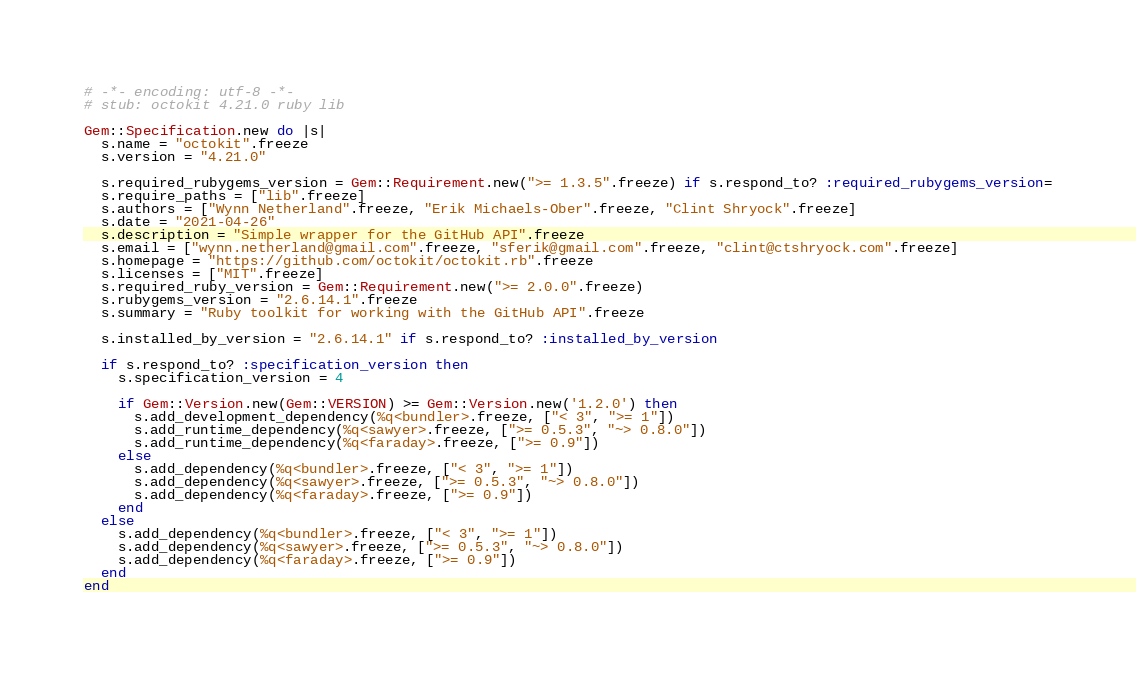Convert code to text. <code><loc_0><loc_0><loc_500><loc_500><_Ruby_># -*- encoding: utf-8 -*-
# stub: octokit 4.21.0 ruby lib

Gem::Specification.new do |s|
  s.name = "octokit".freeze
  s.version = "4.21.0"

  s.required_rubygems_version = Gem::Requirement.new(">= 1.3.5".freeze) if s.respond_to? :required_rubygems_version=
  s.require_paths = ["lib".freeze]
  s.authors = ["Wynn Netherland".freeze, "Erik Michaels-Ober".freeze, "Clint Shryock".freeze]
  s.date = "2021-04-26"
  s.description = "Simple wrapper for the GitHub API".freeze
  s.email = ["wynn.netherland@gmail.com".freeze, "sferik@gmail.com".freeze, "clint@ctshryock.com".freeze]
  s.homepage = "https://github.com/octokit/octokit.rb".freeze
  s.licenses = ["MIT".freeze]
  s.required_ruby_version = Gem::Requirement.new(">= 2.0.0".freeze)
  s.rubygems_version = "2.6.14.1".freeze
  s.summary = "Ruby toolkit for working with the GitHub API".freeze

  s.installed_by_version = "2.6.14.1" if s.respond_to? :installed_by_version

  if s.respond_to? :specification_version then
    s.specification_version = 4

    if Gem::Version.new(Gem::VERSION) >= Gem::Version.new('1.2.0') then
      s.add_development_dependency(%q<bundler>.freeze, ["< 3", ">= 1"])
      s.add_runtime_dependency(%q<sawyer>.freeze, [">= 0.5.3", "~> 0.8.0"])
      s.add_runtime_dependency(%q<faraday>.freeze, [">= 0.9"])
    else
      s.add_dependency(%q<bundler>.freeze, ["< 3", ">= 1"])
      s.add_dependency(%q<sawyer>.freeze, [">= 0.5.3", "~> 0.8.0"])
      s.add_dependency(%q<faraday>.freeze, [">= 0.9"])
    end
  else
    s.add_dependency(%q<bundler>.freeze, ["< 3", ">= 1"])
    s.add_dependency(%q<sawyer>.freeze, [">= 0.5.3", "~> 0.8.0"])
    s.add_dependency(%q<faraday>.freeze, [">= 0.9"])
  end
end
</code> 